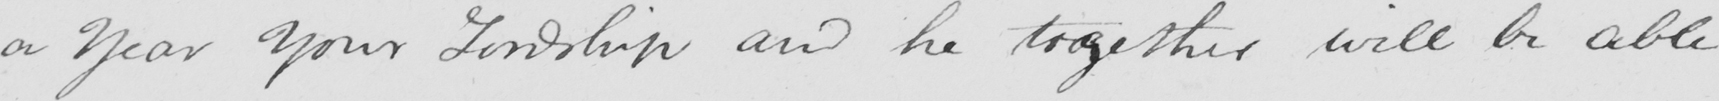What does this handwritten line say? a Year Your Lordship and he together will be able 